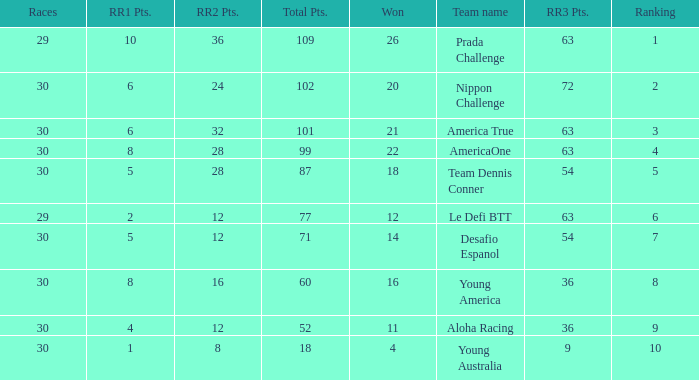What is the ranking for rr2 points when there are 8 points? 10.0. 